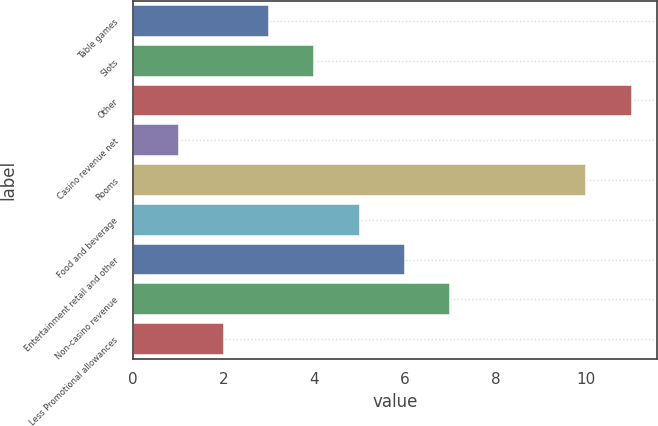<chart> <loc_0><loc_0><loc_500><loc_500><bar_chart><fcel>Table games<fcel>Slots<fcel>Other<fcel>Casino revenue net<fcel>Rooms<fcel>Food and beverage<fcel>Entertainment retail and other<fcel>Non-casino revenue<fcel>Less Promotional allowances<nl><fcel>3<fcel>4<fcel>11<fcel>1<fcel>10<fcel>5<fcel>6<fcel>7<fcel>2<nl></chart> 